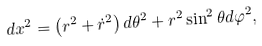<formula> <loc_0><loc_0><loc_500><loc_500>d { x } ^ { 2 } = \left ( r ^ { 2 } + \dot { r } ^ { 2 } \right ) d \theta ^ { 2 } + r ^ { 2 } \sin ^ { 2 } \theta d \varphi ^ { 2 } ,</formula> 